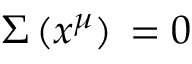<formula> <loc_0><loc_0><loc_500><loc_500>\Sigma \, ( x ^ { \mu } ) \, = 0</formula> 